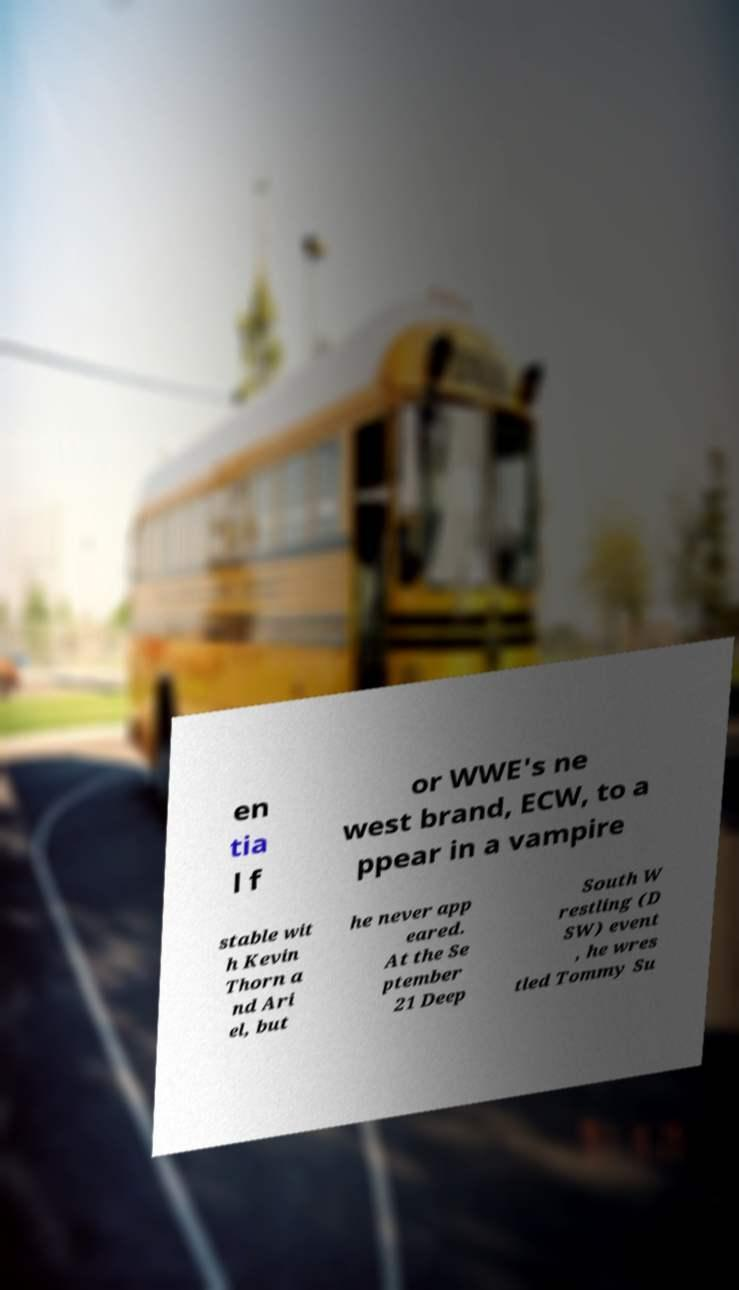Please read and relay the text visible in this image. What does it say? en tia l f or WWE's ne west brand, ECW, to a ppear in a vampire stable wit h Kevin Thorn a nd Ari el, but he never app eared. At the Se ptember 21 Deep South W restling (D SW) event , he wres tled Tommy Su 